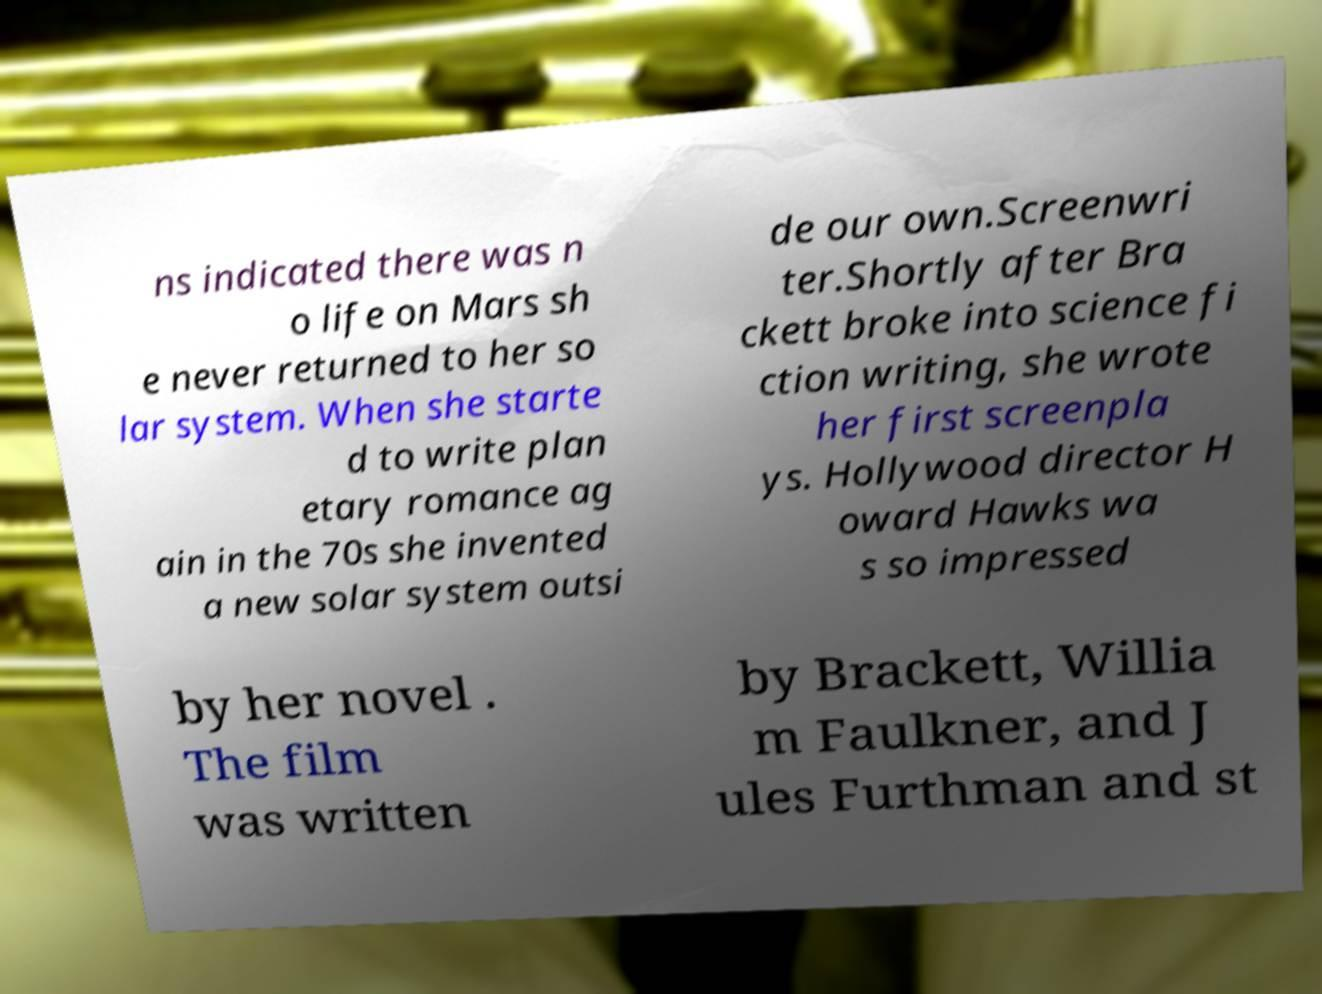Can you accurately transcribe the text from the provided image for me? ns indicated there was n o life on Mars sh e never returned to her so lar system. When she starte d to write plan etary romance ag ain in the 70s she invented a new solar system outsi de our own.Screenwri ter.Shortly after Bra ckett broke into science fi ction writing, she wrote her first screenpla ys. Hollywood director H oward Hawks wa s so impressed by her novel . The film was written by Brackett, Willia m Faulkner, and J ules Furthman and st 